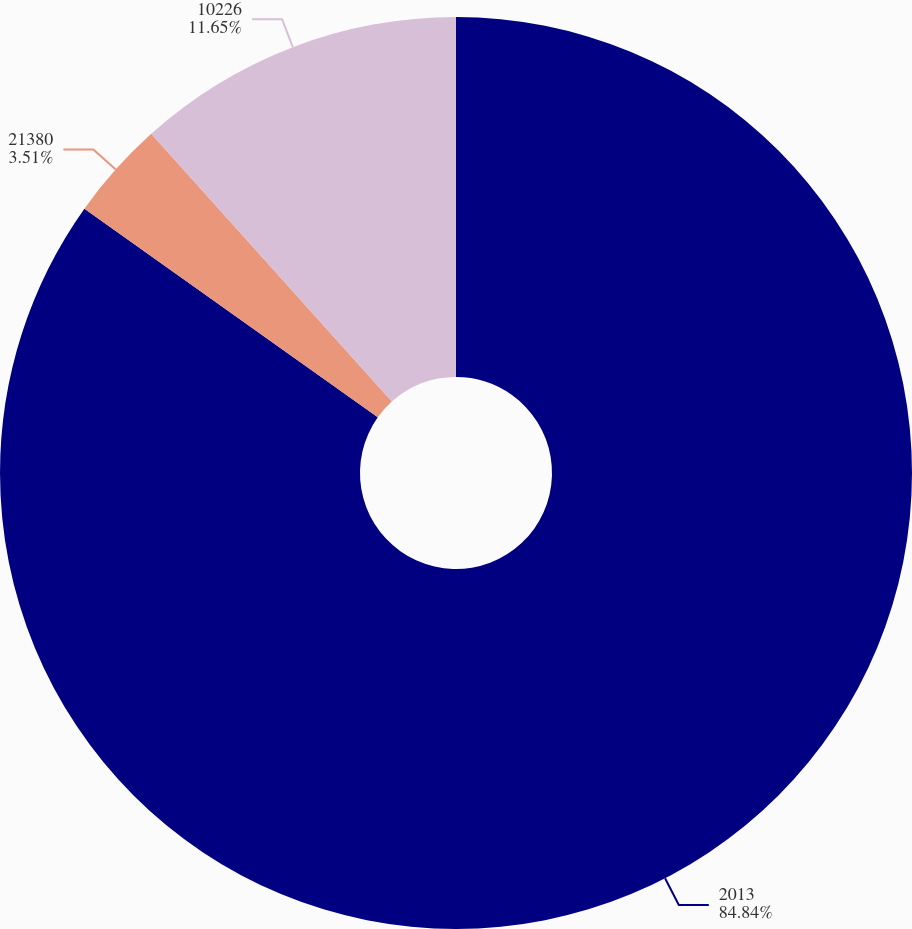<chart> <loc_0><loc_0><loc_500><loc_500><pie_chart><fcel>2013<fcel>21380<fcel>10226<nl><fcel>84.84%<fcel>3.51%<fcel>11.65%<nl></chart> 